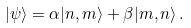<formula> <loc_0><loc_0><loc_500><loc_500>| \psi \rangle = \alpha | n , m \rangle + \beta | m , n \rangle \, .</formula> 